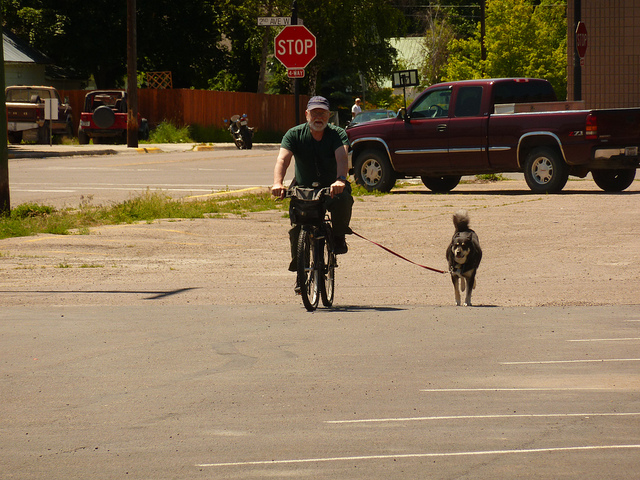Read and extract the text from this image. AVE STOP 